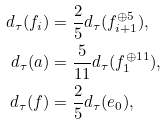Convert formula to latex. <formula><loc_0><loc_0><loc_500><loc_500>d _ { \tau } ( f _ { i } ) & = \frac { 2 } { 5 } d _ { \tau } ( f _ { i + 1 } ^ { \oplus 5 } ) , \\ d _ { \tau } ( a ) & = \frac { 5 } { 1 1 } d _ { \tau } ( f _ { 1 } ^ { \oplus 1 1 } ) , \\ d _ { \tau } ( f ) & = \frac { 2 } { 5 } d _ { \tau } ( e _ { 0 } ) ,</formula> 